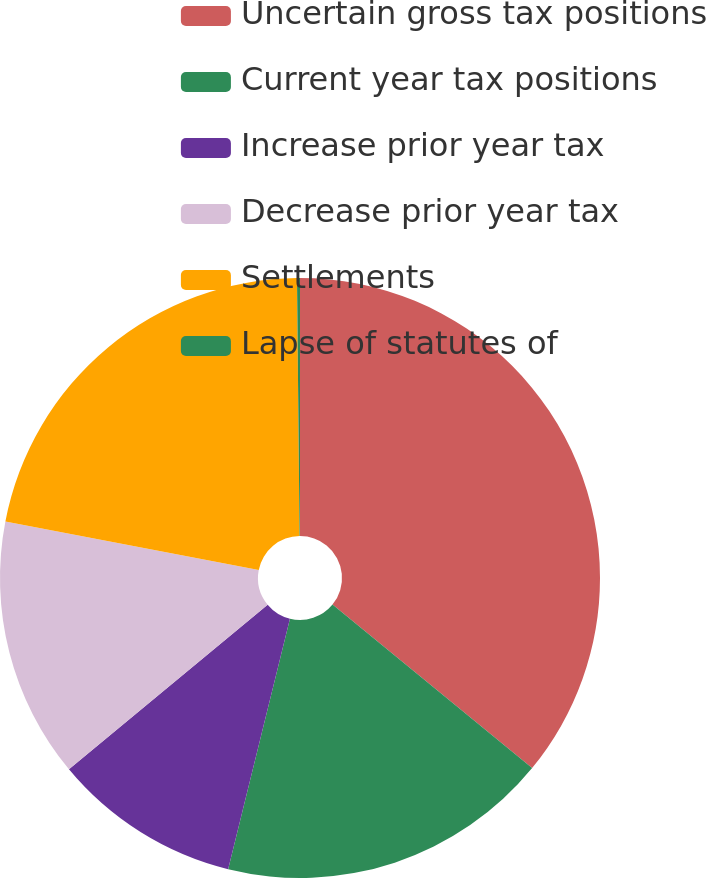Convert chart. <chart><loc_0><loc_0><loc_500><loc_500><pie_chart><fcel>Uncertain gross tax positions<fcel>Current year tax positions<fcel>Increase prior year tax<fcel>Decrease prior year tax<fcel>Settlements<fcel>Lapse of statutes of<nl><fcel>35.92%<fcel>17.93%<fcel>10.14%<fcel>14.03%<fcel>21.82%<fcel>0.16%<nl></chart> 